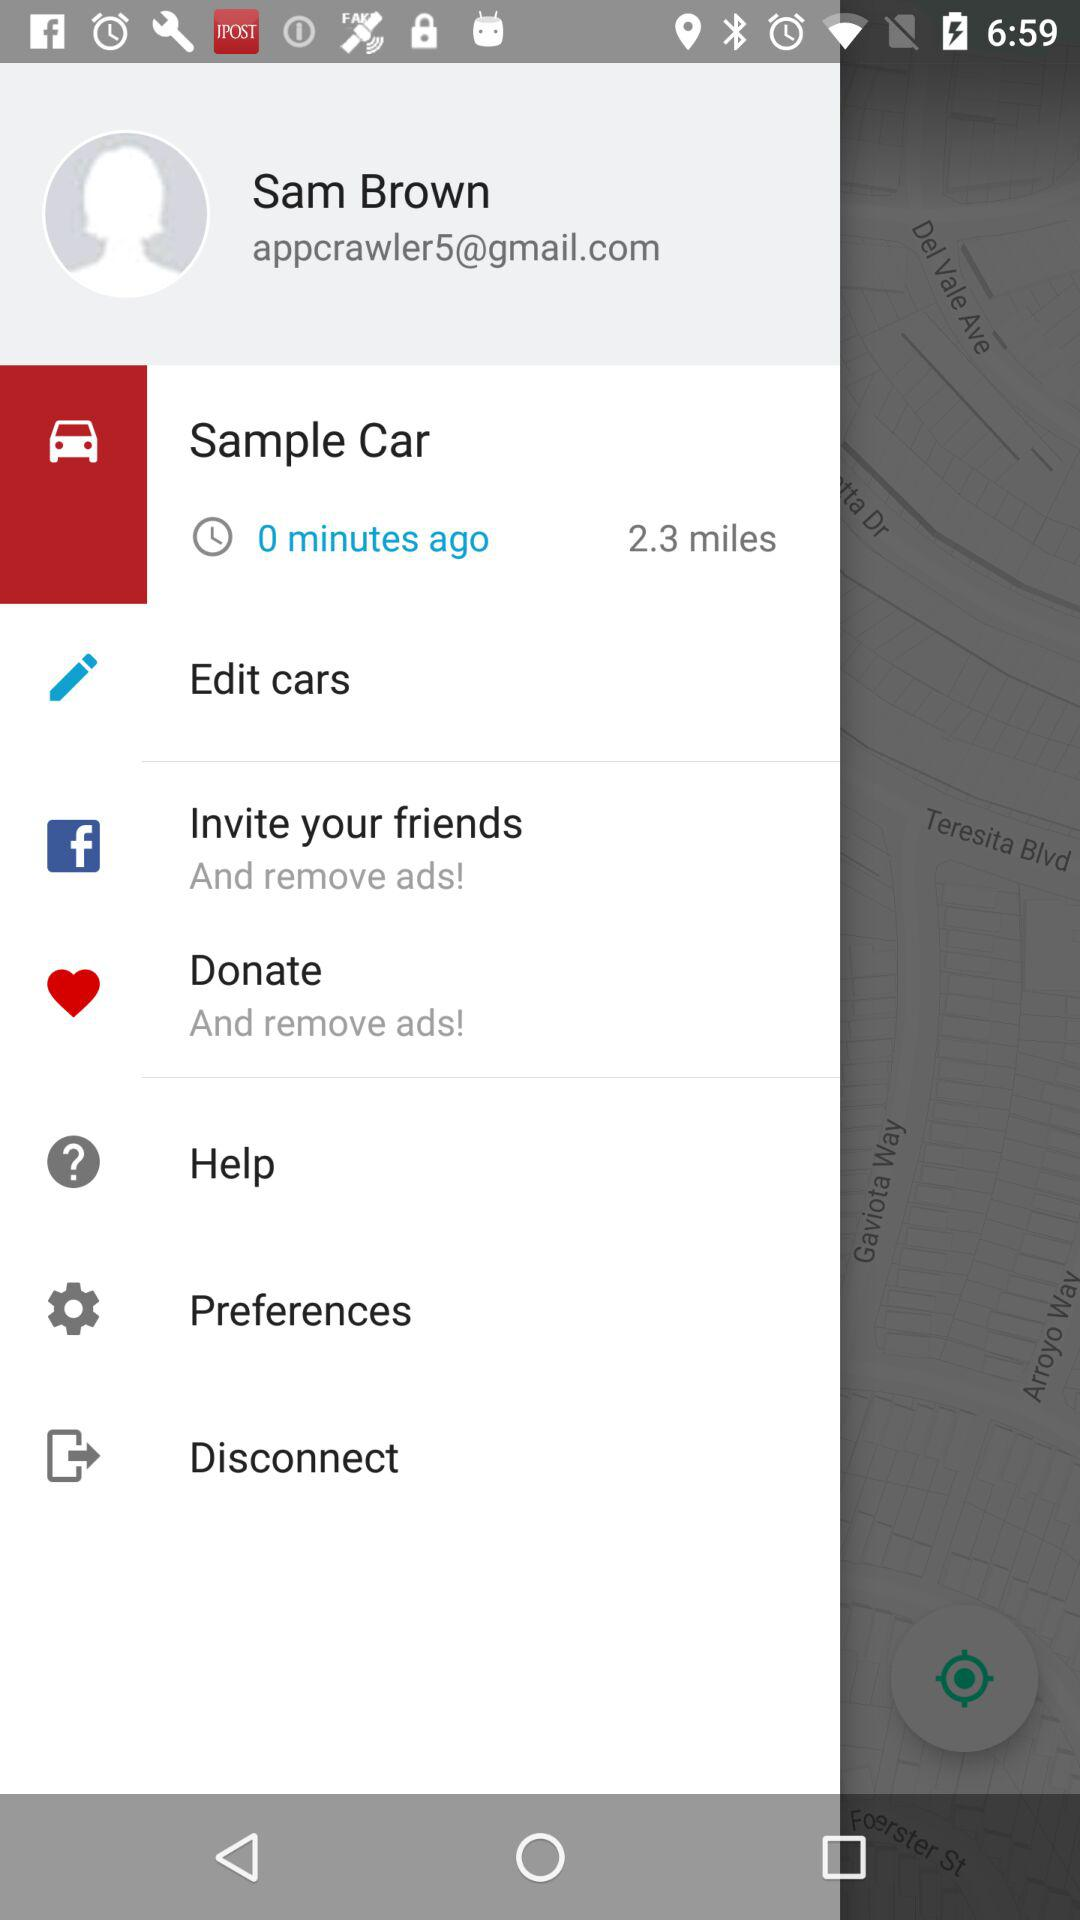Which time is displayed on the screen?
When the provided information is insufficient, respond with <no answer>. <no answer> 